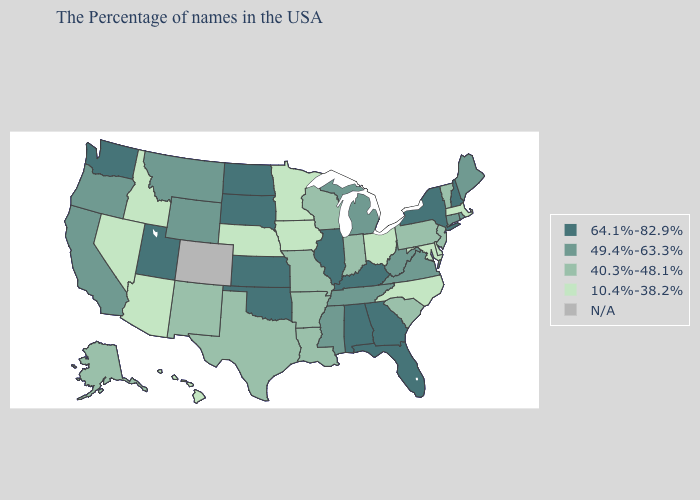What is the value of Virginia?
Quick response, please. 49.4%-63.3%. What is the highest value in the West ?
Quick response, please. 64.1%-82.9%. What is the lowest value in the USA?
Give a very brief answer. 10.4%-38.2%. Does Massachusetts have the lowest value in the Northeast?
Short answer required. Yes. What is the value of Florida?
Quick response, please. 64.1%-82.9%. Is the legend a continuous bar?
Answer briefly. No. What is the lowest value in the USA?
Short answer required. 10.4%-38.2%. What is the highest value in the USA?
Write a very short answer. 64.1%-82.9%. What is the value of North Dakota?
Concise answer only. 64.1%-82.9%. What is the value of Iowa?
Short answer required. 10.4%-38.2%. Which states hav the highest value in the West?
Be succinct. Utah, Washington. What is the value of South Dakota?
Give a very brief answer. 64.1%-82.9%. Among the states that border North Dakota , does Minnesota have the highest value?
Give a very brief answer. No. Does the map have missing data?
Keep it brief. Yes. 